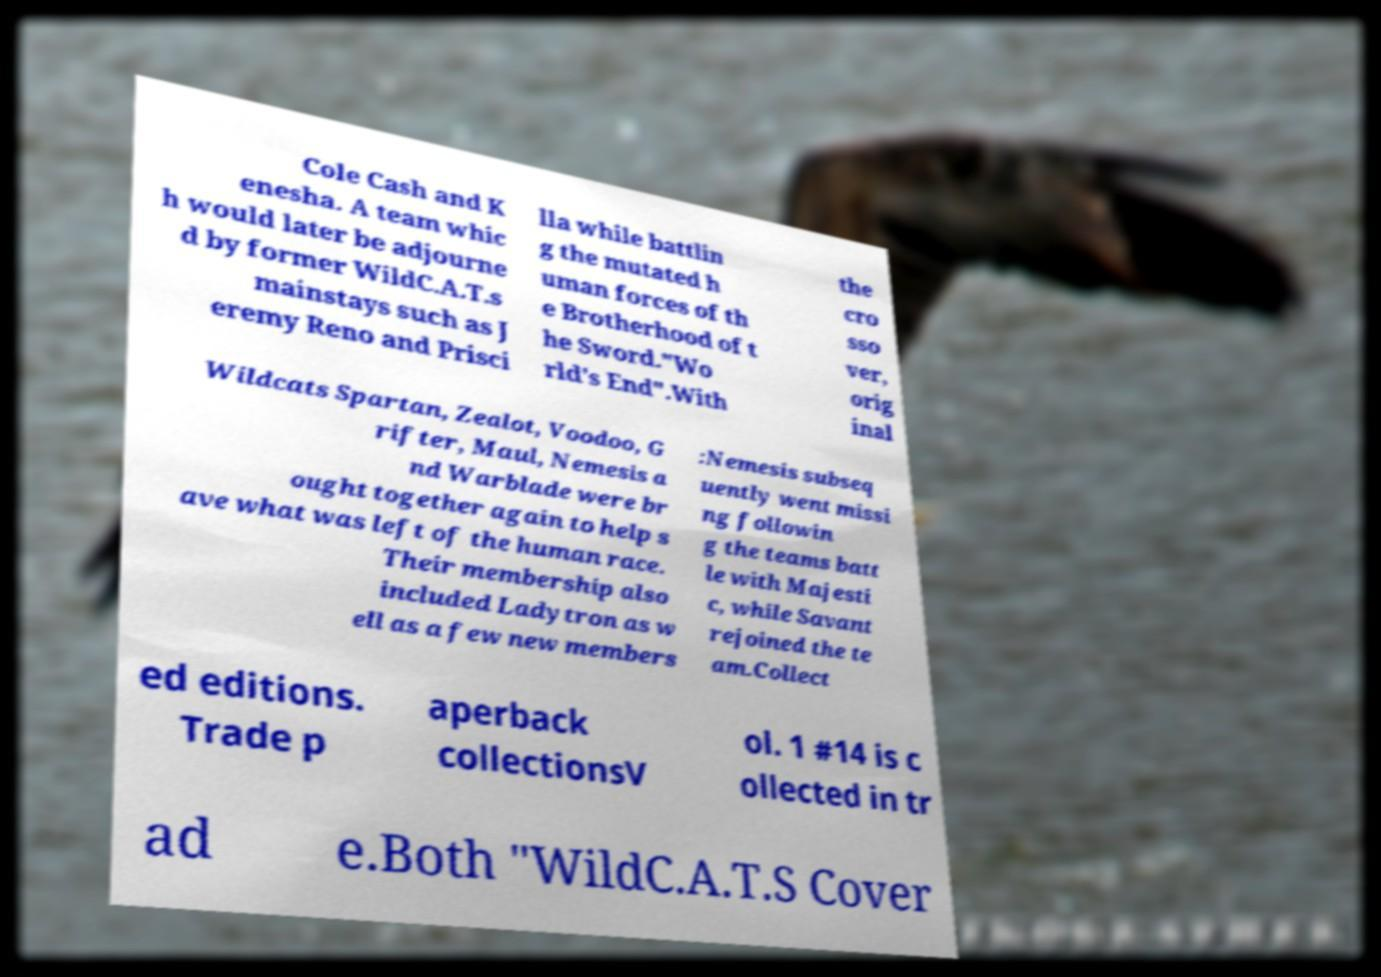Could you extract and type out the text from this image? Cole Cash and K enesha. A team whic h would later be adjourne d by former WildC.A.T.s mainstays such as J eremy Reno and Prisci lla while battlin g the mutated h uman forces of th e Brotherhood of t he Sword."Wo rld's End".With the cro sso ver, orig inal Wildcats Spartan, Zealot, Voodoo, G rifter, Maul, Nemesis a nd Warblade were br ought together again to help s ave what was left of the human race. Their membership also included Ladytron as w ell as a few new members :Nemesis subseq uently went missi ng followin g the teams batt le with Majesti c, while Savant rejoined the te am.Collect ed editions. Trade p aperback collectionsV ol. 1 #14 is c ollected in tr ad e.Both "WildC.A.T.S Cover 